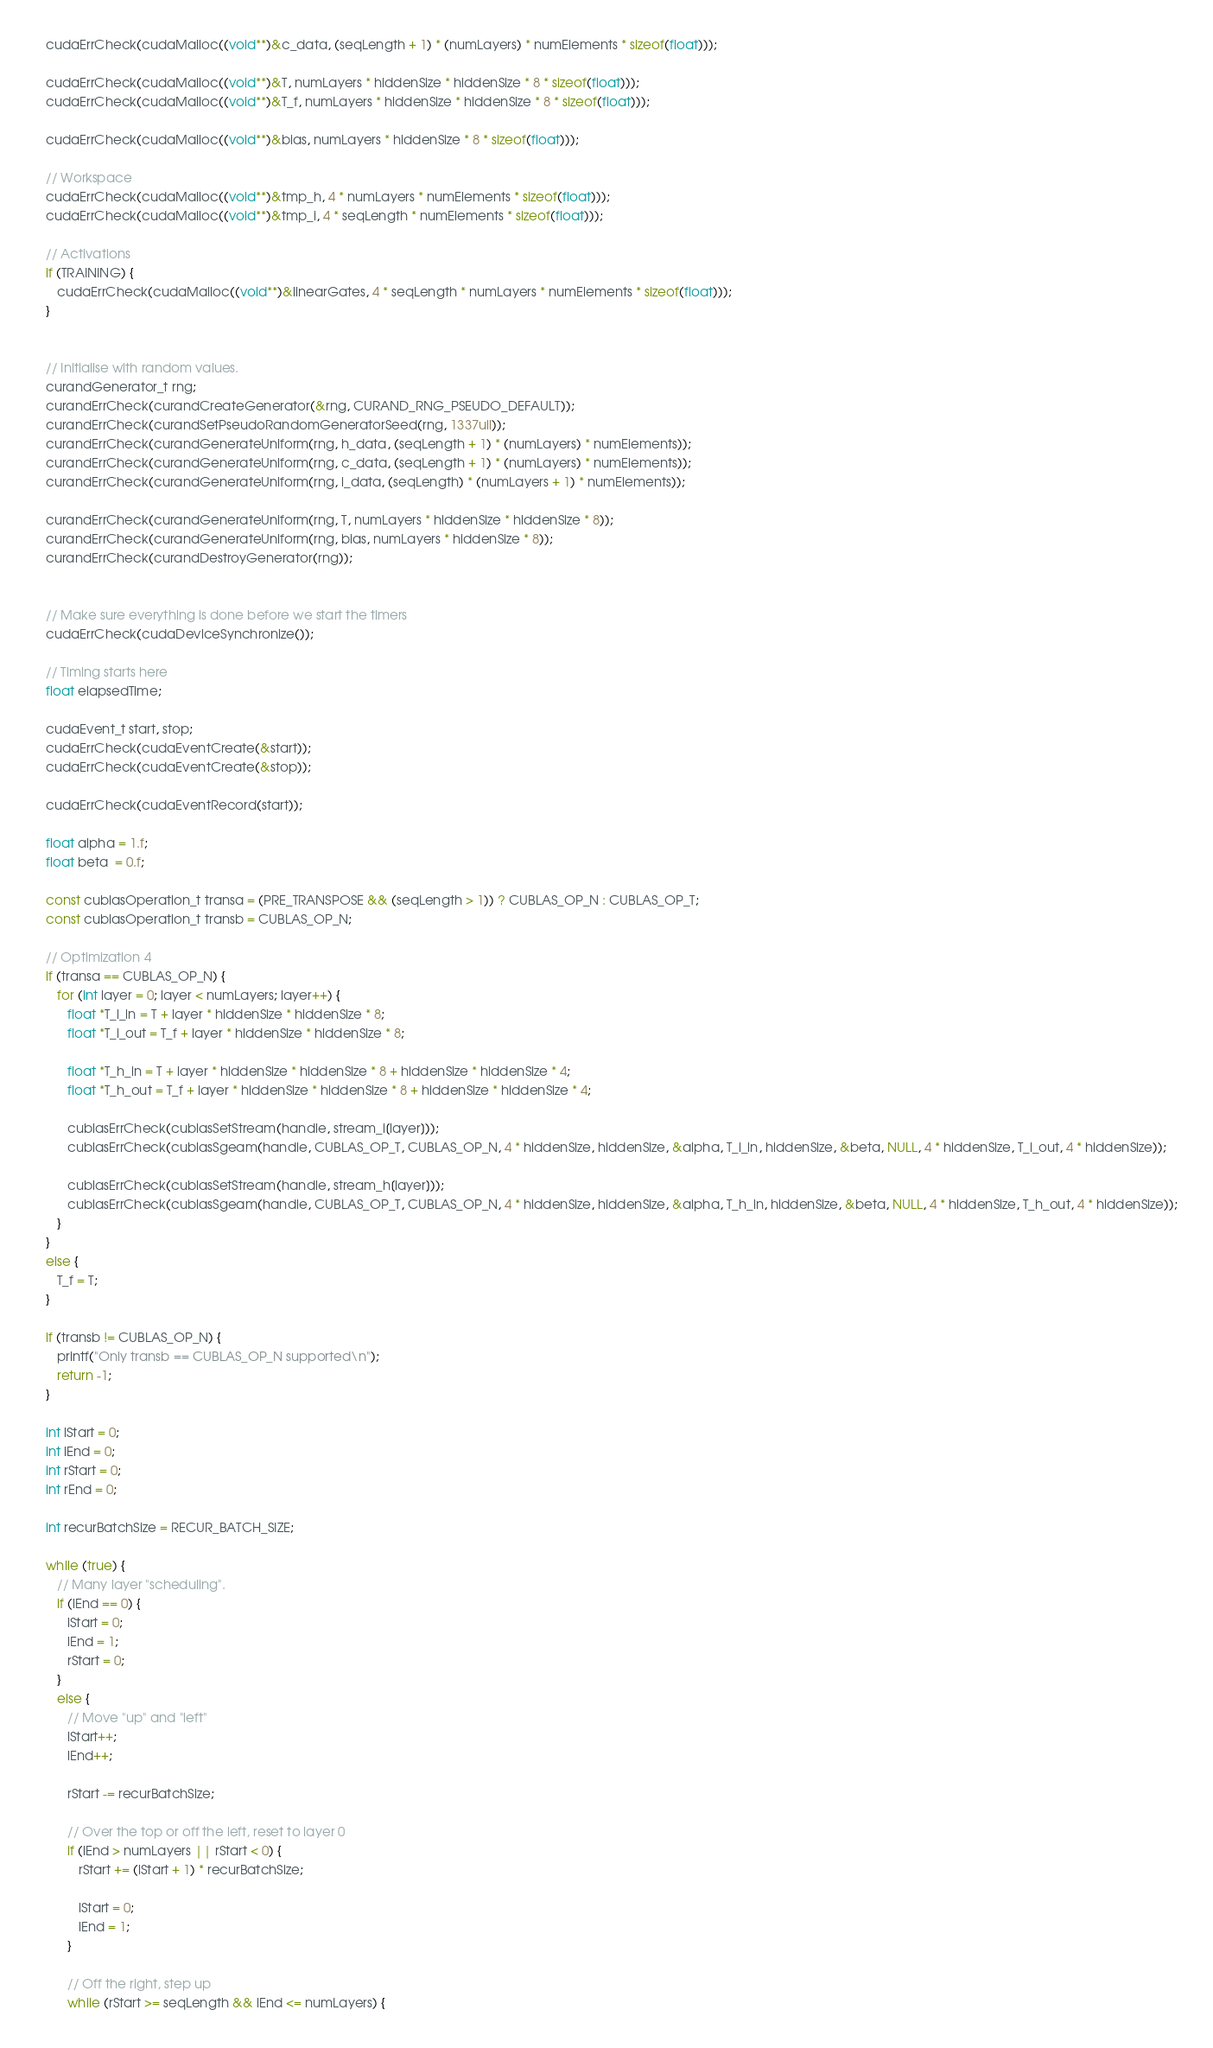Convert code to text. <code><loc_0><loc_0><loc_500><loc_500><_Cuda_>   cudaErrCheck(cudaMalloc((void**)&c_data, (seqLength + 1) * (numLayers) * numElements * sizeof(float)));
   
   cudaErrCheck(cudaMalloc((void**)&T, numLayers * hiddenSize * hiddenSize * 8 * sizeof(float)));
   cudaErrCheck(cudaMalloc((void**)&T_f, numLayers * hiddenSize * hiddenSize * 8 * sizeof(float)));
   
   cudaErrCheck(cudaMalloc((void**)&bias, numLayers * hiddenSize * 8 * sizeof(float)));
   
   // Workspace
   cudaErrCheck(cudaMalloc((void**)&tmp_h, 4 * numLayers * numElements * sizeof(float)));
   cudaErrCheck(cudaMalloc((void**)&tmp_i, 4 * seqLength * numElements * sizeof(float)));
   
   // Activations
   if (TRAINING) {
      cudaErrCheck(cudaMalloc((void**)&linearGates, 4 * seqLength * numLayers * numElements * sizeof(float)));
   }
  

   // Initialise with random values.
   curandGenerator_t rng;
   curandErrCheck(curandCreateGenerator(&rng, CURAND_RNG_PSEUDO_DEFAULT));
   curandErrCheck(curandSetPseudoRandomGeneratorSeed(rng, 1337ull));
   curandErrCheck(curandGenerateUniform(rng, h_data, (seqLength + 1) * (numLayers) * numElements));
   curandErrCheck(curandGenerateUniform(rng, c_data, (seqLength + 1) * (numLayers) * numElements));
   curandErrCheck(curandGenerateUniform(rng, i_data, (seqLength) * (numLayers + 1) * numElements));
   
   curandErrCheck(curandGenerateUniform(rng, T, numLayers * hiddenSize * hiddenSize * 8));
   curandErrCheck(curandGenerateUniform(rng, bias, numLayers * hiddenSize * 8));
   curandErrCheck(curandDestroyGenerator(rng));

   
   // Make sure everything is done before we start the timers
   cudaErrCheck(cudaDeviceSynchronize());
  
   // Timing starts here
   float elapsedTime;
   
   cudaEvent_t start, stop;
   cudaErrCheck(cudaEventCreate(&start));
   cudaErrCheck(cudaEventCreate(&stop));

   cudaErrCheck(cudaEventRecord(start));
  
   float alpha = 1.f;
   float beta  = 0.f;      
   
   const cublasOperation_t transa = (PRE_TRANSPOSE && (seqLength > 1)) ? CUBLAS_OP_N : CUBLAS_OP_T;
   const cublasOperation_t transb = CUBLAS_OP_N;
   
   // Optimization 4
   if (transa == CUBLAS_OP_N) {      
      for (int layer = 0; layer < numLayers; layer++) {                     
         float *T_i_in = T + layer * hiddenSize * hiddenSize * 8;
         float *T_i_out = T_f + layer * hiddenSize * hiddenSize * 8;

         float *T_h_in = T + layer * hiddenSize * hiddenSize * 8 + hiddenSize * hiddenSize * 4;
         float *T_h_out = T_f + layer * hiddenSize * hiddenSize * 8 + hiddenSize * hiddenSize * 4;

         cublasErrCheck(cublasSetStream(handle, stream_i[layer]));
         cublasErrCheck(cublasSgeam(handle, CUBLAS_OP_T, CUBLAS_OP_N, 4 * hiddenSize, hiddenSize, &alpha, T_i_in, hiddenSize, &beta, NULL, 4 * hiddenSize, T_i_out, 4 * hiddenSize));
         
         cublasErrCheck(cublasSetStream(handle, stream_h[layer]));
         cublasErrCheck(cublasSgeam(handle, CUBLAS_OP_T, CUBLAS_OP_N, 4 * hiddenSize, hiddenSize, &alpha, T_h_in, hiddenSize, &beta, NULL, 4 * hiddenSize, T_h_out, 4 * hiddenSize));
      }      
   }
   else {
      T_f = T;
   }
   
   if (transb != CUBLAS_OP_N) {
      printf("Only transb == CUBLAS_OP_N supported\n");
      return -1;
   }
   
   int lStart = 0;
   int lEnd = 0;
   int rStart = 0;
   int rEnd = 0;
   
   int recurBatchSize = RECUR_BATCH_SIZE;
   
   while (true) {
      // Many layer "scheduling".
      if (lEnd == 0) {
         lStart = 0;
         lEnd = 1;
         rStart = 0;
      }
      else {
         // Move "up" and "left"
         lStart++;
         lEnd++;
         
         rStart -= recurBatchSize;
         
         // Over the top or off the left, reset to layer 0
         if (lEnd > numLayers || rStart < 0) {
            rStart += (lStart + 1) * recurBatchSize;

            lStart = 0;
            lEnd = 1;
         }
         
         // Off the right, step up
         while (rStart >= seqLength && lEnd <= numLayers) {</code> 